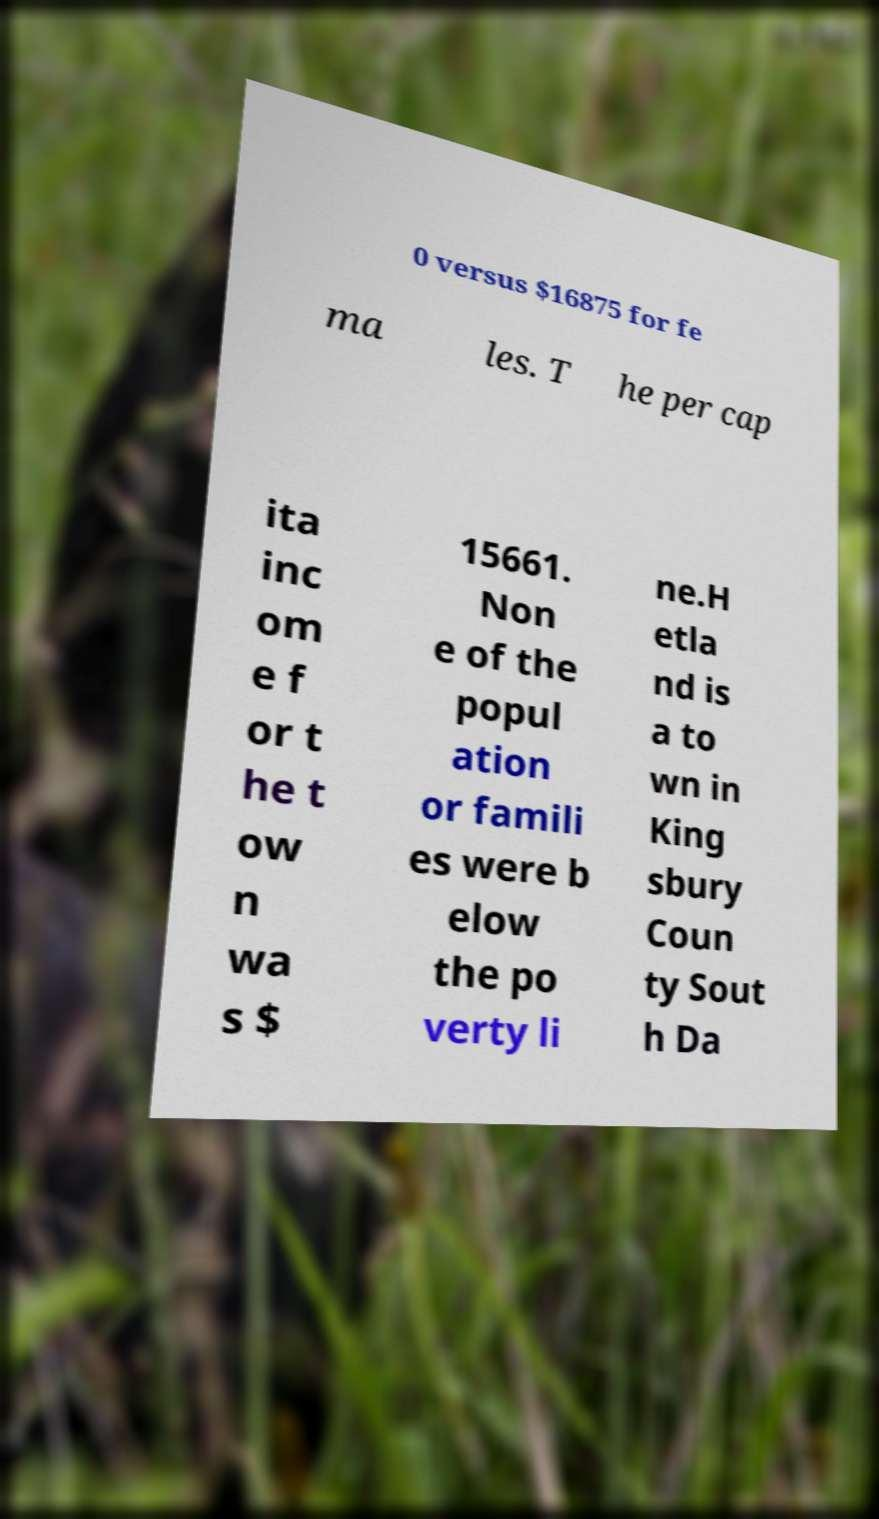There's text embedded in this image that I need extracted. Can you transcribe it verbatim? 0 versus $16875 for fe ma les. T he per cap ita inc om e f or t he t ow n wa s $ 15661. Non e of the popul ation or famili es were b elow the po verty li ne.H etla nd is a to wn in King sbury Coun ty Sout h Da 